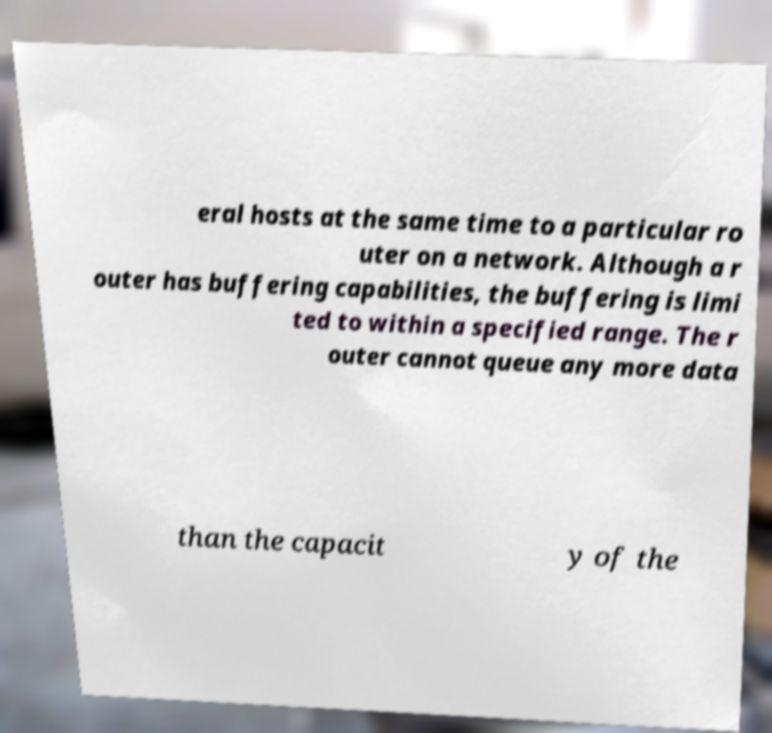Can you accurately transcribe the text from the provided image for me? eral hosts at the same time to a particular ro uter on a network. Although a r outer has buffering capabilities, the buffering is limi ted to within a specified range. The r outer cannot queue any more data than the capacit y of the 